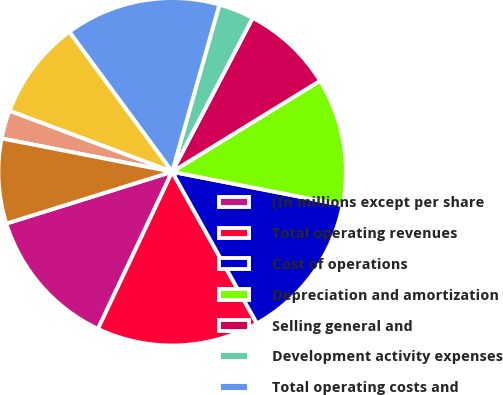<chart> <loc_0><loc_0><loc_500><loc_500><pie_chart><fcel>(In millions except per share<fcel>Total operating revenues<fcel>Cost of operations<fcel>Depreciation and amortization<fcel>Selling general and<fcel>Development activity expenses<fcel>Total operating costs and<fcel>Operating Income<fcel>Equity in earnings of<fcel>Impairment losses on<nl><fcel>13.16%<fcel>15.13%<fcel>13.82%<fcel>11.84%<fcel>8.55%<fcel>3.29%<fcel>14.47%<fcel>9.21%<fcel>2.63%<fcel>7.89%<nl></chart> 